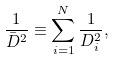Convert formula to latex. <formula><loc_0><loc_0><loc_500><loc_500>\frac { 1 } { { \bar { D } } ^ { 2 } } \equiv \sum _ { i = 1 } ^ { N } \frac { 1 } { D _ { i } ^ { 2 } } ,</formula> 